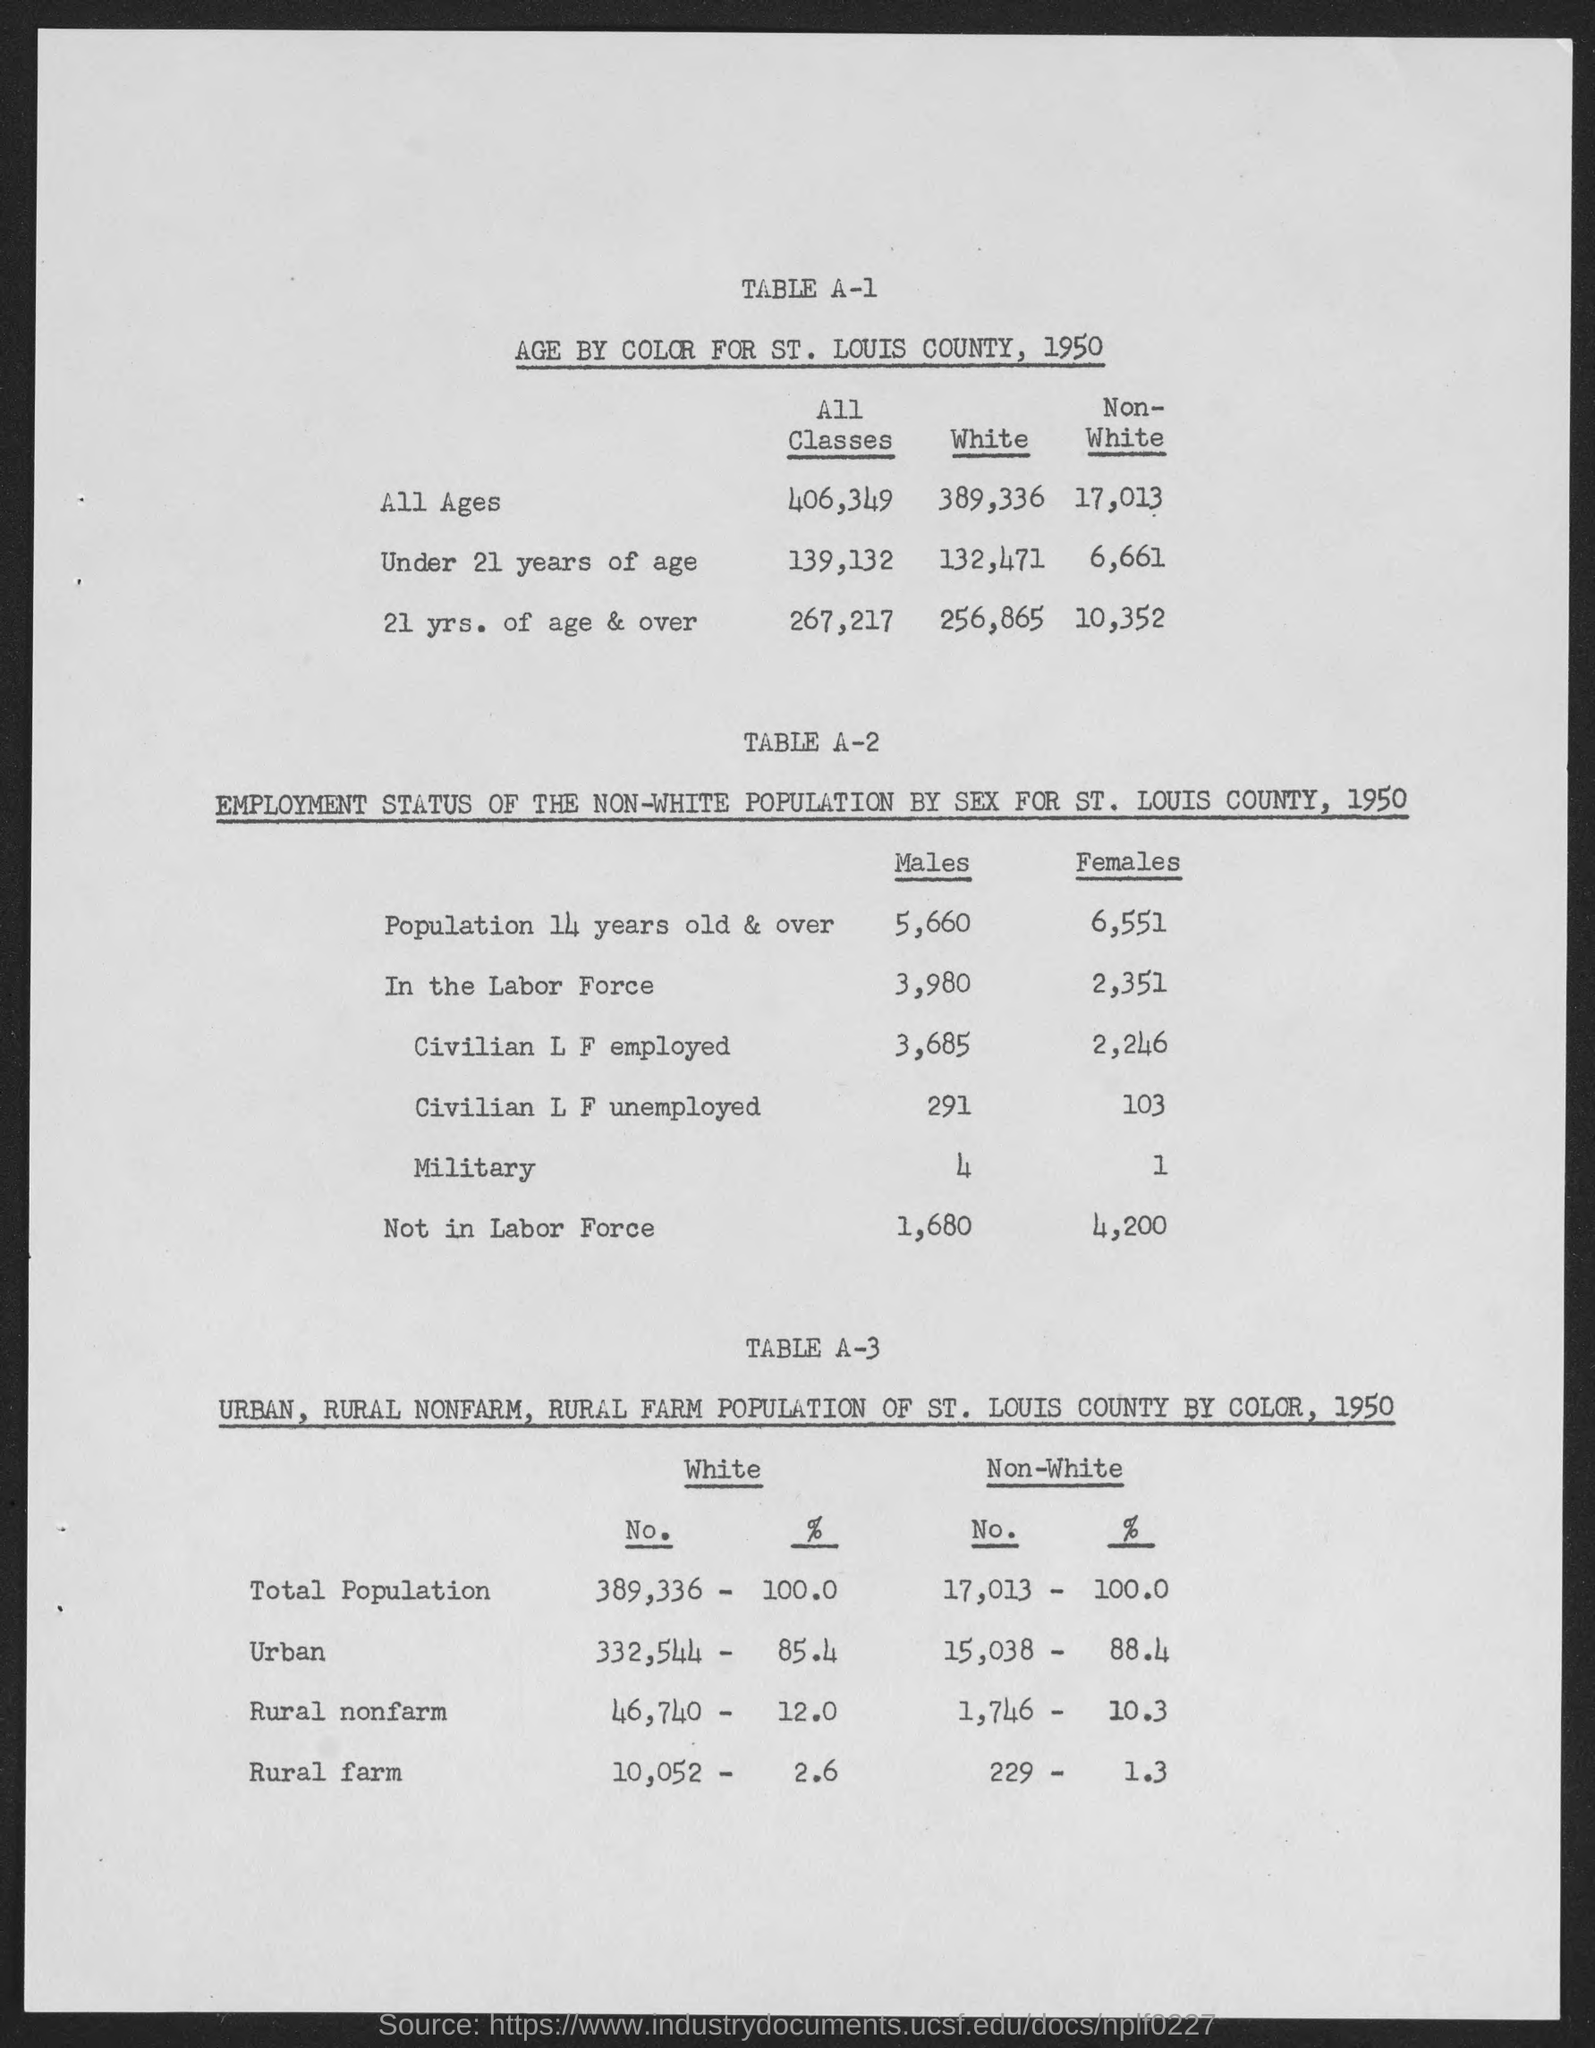Can you tell me more about the employment status of the non-white population in St. Louis county, 1950? Certainly! In 1950 St. Louis County, the non-white population aged 14 years and older had 5,660 males and 6,551 females. Out of these, 3,980 males and 2,351 females were part of the labor force. Among those in the labor force, 3,685 males and 2,246 females were employed. 